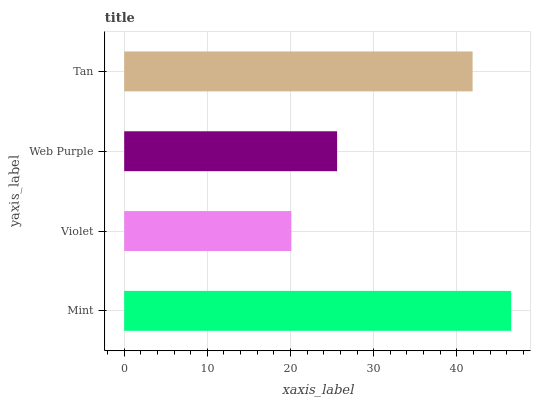Is Violet the minimum?
Answer yes or no. Yes. Is Mint the maximum?
Answer yes or no. Yes. Is Web Purple the minimum?
Answer yes or no. No. Is Web Purple the maximum?
Answer yes or no. No. Is Web Purple greater than Violet?
Answer yes or no. Yes. Is Violet less than Web Purple?
Answer yes or no. Yes. Is Violet greater than Web Purple?
Answer yes or no. No. Is Web Purple less than Violet?
Answer yes or no. No. Is Tan the high median?
Answer yes or no. Yes. Is Web Purple the low median?
Answer yes or no. Yes. Is Web Purple the high median?
Answer yes or no. No. Is Mint the low median?
Answer yes or no. No. 